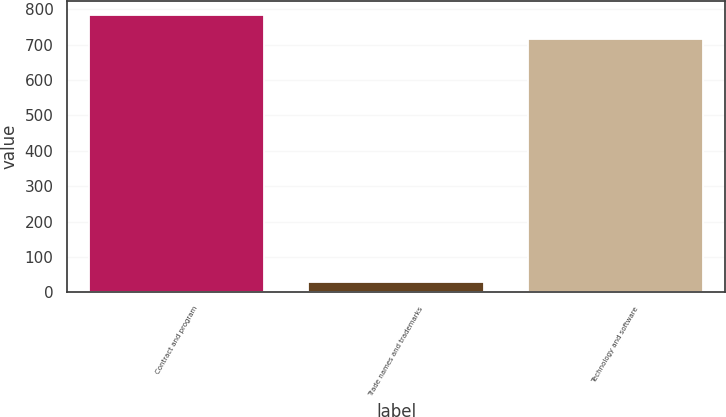Convert chart to OTSL. <chart><loc_0><loc_0><loc_500><loc_500><bar_chart><fcel>Contract and program<fcel>Trade names and trademarks<fcel>Technology and software<nl><fcel>785<fcel>30<fcel>715<nl></chart> 